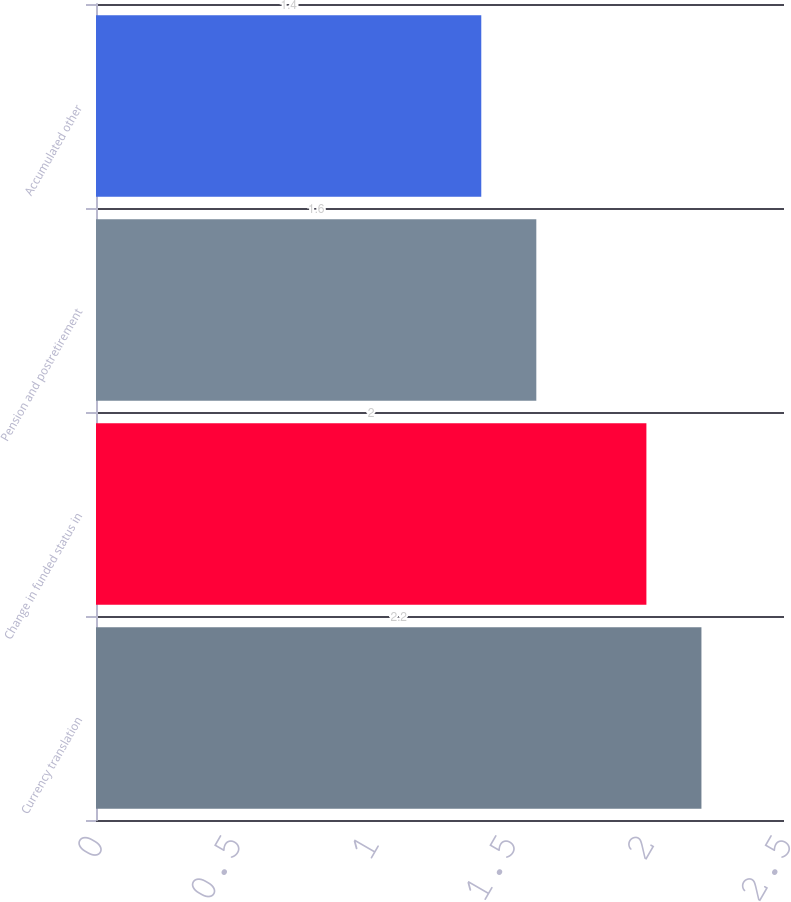Convert chart to OTSL. <chart><loc_0><loc_0><loc_500><loc_500><bar_chart><fcel>Currency translation<fcel>Change in funded status in<fcel>Pension and postretirement<fcel>Accumulated other<nl><fcel>2.2<fcel>2<fcel>1.6<fcel>1.4<nl></chart> 